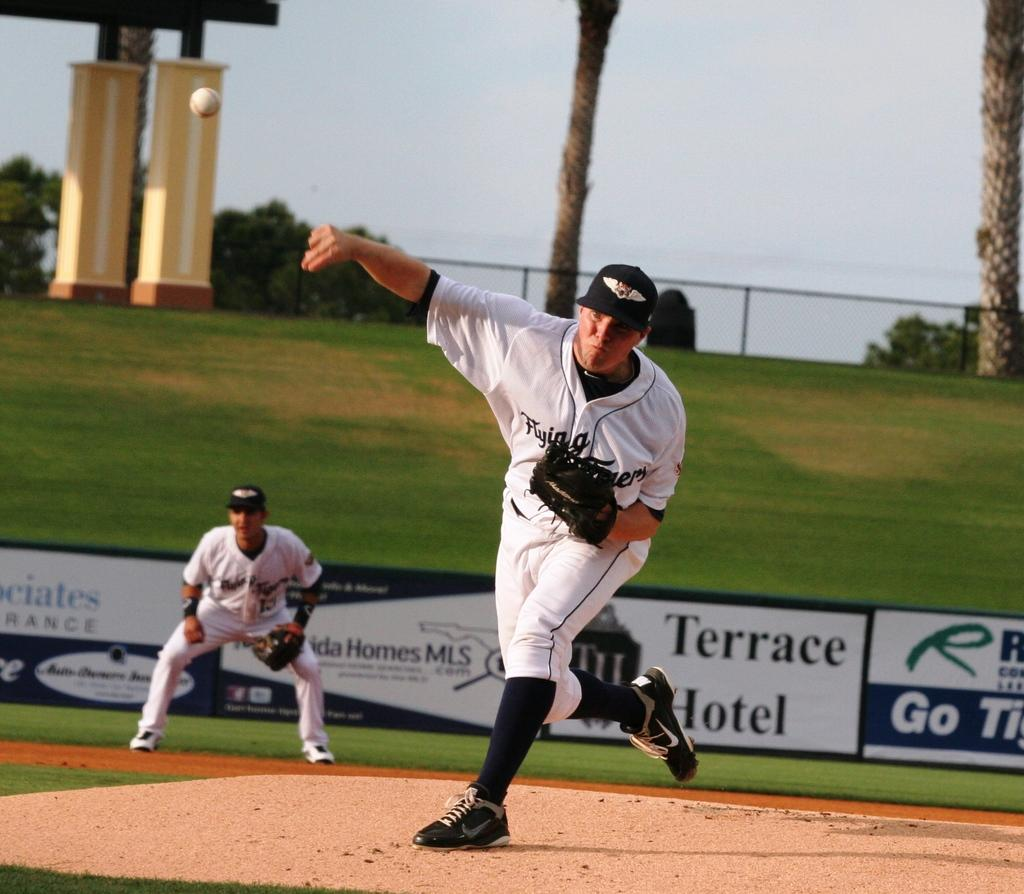<image>
Give a short and clear explanation of the subsequent image. A baseball player in white pitching in front of an advertisement for the Terrace Hotel. 